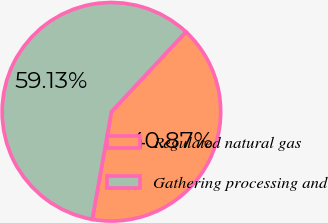Convert chart. <chart><loc_0><loc_0><loc_500><loc_500><pie_chart><fcel>Regulated natural gas<fcel>Gathering processing and<nl><fcel>40.87%<fcel>59.13%<nl></chart> 